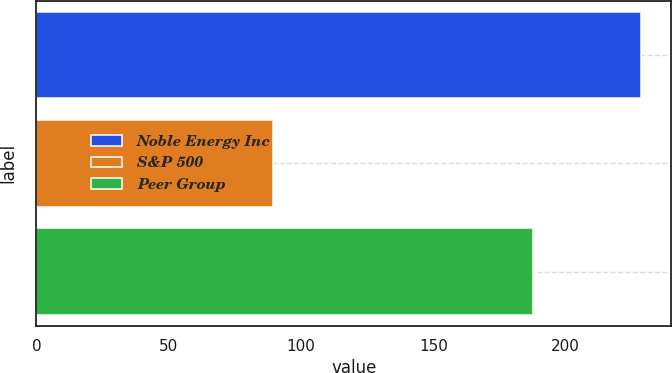Convert chart to OTSL. <chart><loc_0><loc_0><loc_500><loc_500><bar_chart><fcel>Noble Energy Inc<fcel>S&P 500<fcel>Peer Group<nl><fcel>228.44<fcel>89.53<fcel>187.65<nl></chart> 